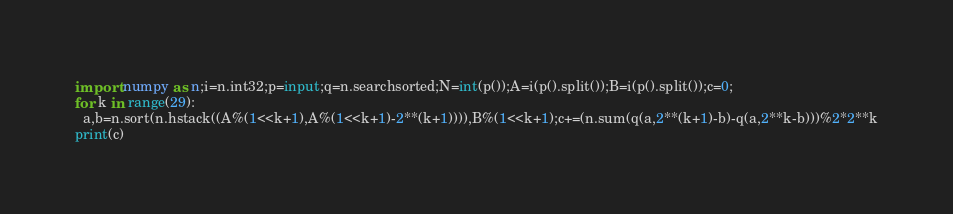Convert code to text. <code><loc_0><loc_0><loc_500><loc_500><_Python_>import numpy as n;i=n.int32;p=input;q=n.searchsorted;N=int(p());A=i(p().split());B=i(p().split());c=0;
for k in range(29):
  a,b=n.sort(n.hstack((A%(1<<k+1),A%(1<<k+1)-2**(k+1)))),B%(1<<k+1);c+=(n.sum(q(a,2**(k+1)-b)-q(a,2**k-b)))%2*2**k
print(c)
</code> 